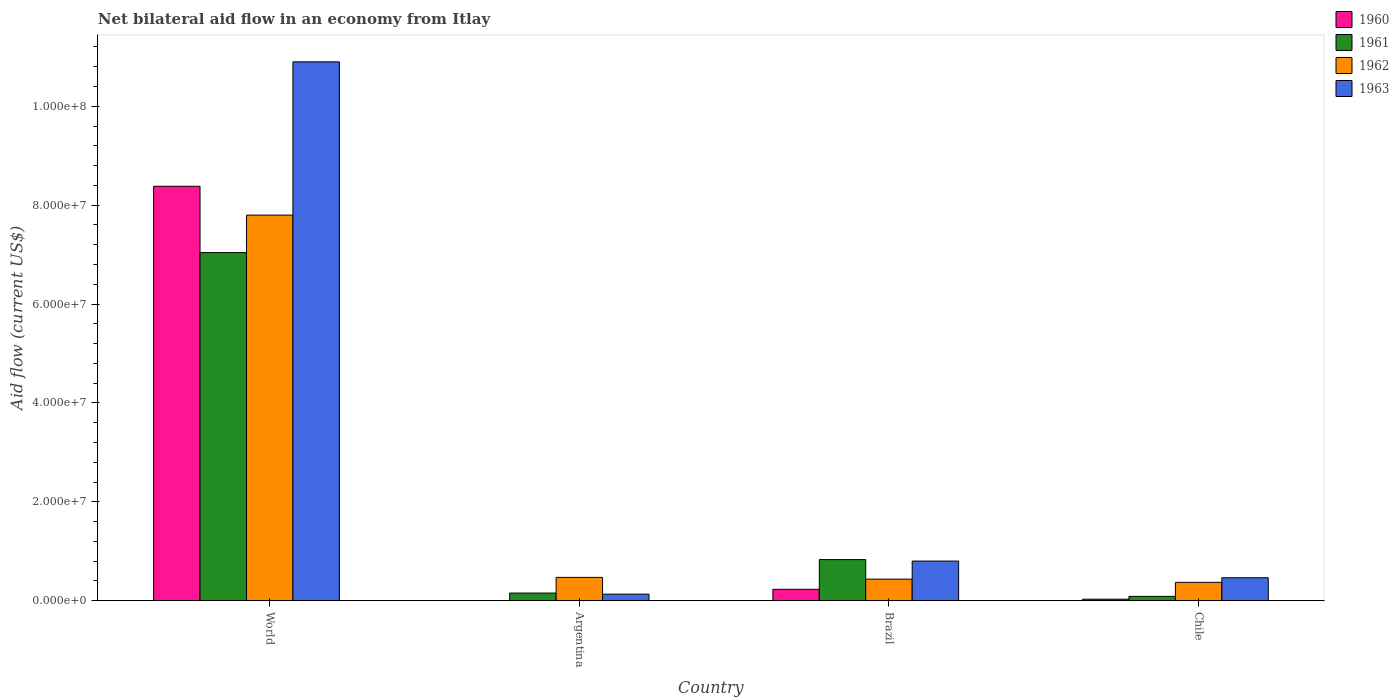How many different coloured bars are there?
Offer a terse response. 4. How many groups of bars are there?
Your answer should be very brief. 4. Are the number of bars per tick equal to the number of legend labels?
Your answer should be compact. No. How many bars are there on the 4th tick from the left?
Provide a short and direct response. 4. How many bars are there on the 4th tick from the right?
Offer a terse response. 4. In how many cases, is the number of bars for a given country not equal to the number of legend labels?
Make the answer very short. 1. What is the net bilateral aid flow in 1961 in Chile?
Your answer should be very brief. 8.90e+05. Across all countries, what is the maximum net bilateral aid flow in 1961?
Offer a terse response. 7.04e+07. In which country was the net bilateral aid flow in 1963 maximum?
Offer a very short reply. World. What is the total net bilateral aid flow in 1963 in the graph?
Make the answer very short. 1.23e+08. What is the difference between the net bilateral aid flow in 1960 in Brazil and that in World?
Your answer should be very brief. -8.15e+07. What is the difference between the net bilateral aid flow in 1961 in Brazil and the net bilateral aid flow in 1962 in Chile?
Provide a succinct answer. 4.60e+06. What is the average net bilateral aid flow in 1961 per country?
Ensure brevity in your answer.  2.03e+07. What is the difference between the net bilateral aid flow of/in 1963 and net bilateral aid flow of/in 1961 in Chile?
Your response must be concise. 3.77e+06. What is the ratio of the net bilateral aid flow in 1961 in Argentina to that in World?
Your response must be concise. 0.02. What is the difference between the highest and the second highest net bilateral aid flow in 1963?
Your response must be concise. 1.04e+08. What is the difference between the highest and the lowest net bilateral aid flow in 1962?
Make the answer very short. 7.43e+07. In how many countries, is the net bilateral aid flow in 1961 greater than the average net bilateral aid flow in 1961 taken over all countries?
Keep it short and to the point. 1. Is the sum of the net bilateral aid flow in 1962 in Argentina and Chile greater than the maximum net bilateral aid flow in 1961 across all countries?
Offer a very short reply. No. Is it the case that in every country, the sum of the net bilateral aid flow in 1963 and net bilateral aid flow in 1960 is greater than the sum of net bilateral aid flow in 1961 and net bilateral aid flow in 1962?
Make the answer very short. No. Are all the bars in the graph horizontal?
Make the answer very short. No. How many countries are there in the graph?
Give a very brief answer. 4. What is the difference between two consecutive major ticks on the Y-axis?
Offer a very short reply. 2.00e+07. Are the values on the major ticks of Y-axis written in scientific E-notation?
Your response must be concise. Yes. Does the graph contain any zero values?
Offer a terse response. Yes. Does the graph contain grids?
Offer a very short reply. No. Where does the legend appear in the graph?
Give a very brief answer. Top right. How many legend labels are there?
Your answer should be very brief. 4. What is the title of the graph?
Offer a terse response. Net bilateral aid flow in an economy from Itlay. Does "1987" appear as one of the legend labels in the graph?
Your answer should be compact. No. What is the label or title of the X-axis?
Provide a short and direct response. Country. What is the Aid flow (current US$) in 1960 in World?
Provide a succinct answer. 8.38e+07. What is the Aid flow (current US$) of 1961 in World?
Your answer should be very brief. 7.04e+07. What is the Aid flow (current US$) in 1962 in World?
Offer a terse response. 7.80e+07. What is the Aid flow (current US$) in 1963 in World?
Your answer should be very brief. 1.09e+08. What is the Aid flow (current US$) of 1960 in Argentina?
Offer a terse response. 0. What is the Aid flow (current US$) of 1961 in Argentina?
Your answer should be very brief. 1.56e+06. What is the Aid flow (current US$) of 1962 in Argentina?
Provide a succinct answer. 4.73e+06. What is the Aid flow (current US$) of 1963 in Argentina?
Your answer should be very brief. 1.34e+06. What is the Aid flow (current US$) in 1960 in Brazil?
Your answer should be very brief. 2.32e+06. What is the Aid flow (current US$) of 1961 in Brazil?
Offer a terse response. 8.33e+06. What is the Aid flow (current US$) of 1962 in Brazil?
Offer a terse response. 4.38e+06. What is the Aid flow (current US$) of 1963 in Brazil?
Provide a succinct answer. 8.03e+06. What is the Aid flow (current US$) in 1961 in Chile?
Offer a very short reply. 8.90e+05. What is the Aid flow (current US$) in 1962 in Chile?
Provide a succinct answer. 3.73e+06. What is the Aid flow (current US$) in 1963 in Chile?
Your answer should be very brief. 4.66e+06. Across all countries, what is the maximum Aid flow (current US$) in 1960?
Provide a succinct answer. 8.38e+07. Across all countries, what is the maximum Aid flow (current US$) in 1961?
Your answer should be very brief. 7.04e+07. Across all countries, what is the maximum Aid flow (current US$) in 1962?
Ensure brevity in your answer.  7.80e+07. Across all countries, what is the maximum Aid flow (current US$) of 1963?
Provide a short and direct response. 1.09e+08. Across all countries, what is the minimum Aid flow (current US$) in 1960?
Your response must be concise. 0. Across all countries, what is the minimum Aid flow (current US$) in 1961?
Offer a terse response. 8.90e+05. Across all countries, what is the minimum Aid flow (current US$) of 1962?
Make the answer very short. 3.73e+06. Across all countries, what is the minimum Aid flow (current US$) in 1963?
Your answer should be very brief. 1.34e+06. What is the total Aid flow (current US$) of 1960 in the graph?
Offer a very short reply. 8.65e+07. What is the total Aid flow (current US$) in 1961 in the graph?
Provide a succinct answer. 8.12e+07. What is the total Aid flow (current US$) in 1962 in the graph?
Keep it short and to the point. 9.08e+07. What is the total Aid flow (current US$) in 1963 in the graph?
Provide a succinct answer. 1.23e+08. What is the difference between the Aid flow (current US$) in 1961 in World and that in Argentina?
Provide a short and direct response. 6.89e+07. What is the difference between the Aid flow (current US$) in 1962 in World and that in Argentina?
Your answer should be compact. 7.33e+07. What is the difference between the Aid flow (current US$) in 1963 in World and that in Argentina?
Give a very brief answer. 1.08e+08. What is the difference between the Aid flow (current US$) in 1960 in World and that in Brazil?
Your response must be concise. 8.15e+07. What is the difference between the Aid flow (current US$) in 1961 in World and that in Brazil?
Make the answer very short. 6.21e+07. What is the difference between the Aid flow (current US$) of 1962 in World and that in Brazil?
Your answer should be very brief. 7.36e+07. What is the difference between the Aid flow (current US$) of 1963 in World and that in Brazil?
Give a very brief answer. 1.01e+08. What is the difference between the Aid flow (current US$) of 1960 in World and that in Chile?
Make the answer very short. 8.35e+07. What is the difference between the Aid flow (current US$) of 1961 in World and that in Chile?
Keep it short and to the point. 6.95e+07. What is the difference between the Aid flow (current US$) of 1962 in World and that in Chile?
Ensure brevity in your answer.  7.43e+07. What is the difference between the Aid flow (current US$) in 1963 in World and that in Chile?
Your answer should be very brief. 1.04e+08. What is the difference between the Aid flow (current US$) of 1961 in Argentina and that in Brazil?
Make the answer very short. -6.77e+06. What is the difference between the Aid flow (current US$) in 1962 in Argentina and that in Brazil?
Keep it short and to the point. 3.50e+05. What is the difference between the Aid flow (current US$) of 1963 in Argentina and that in Brazil?
Offer a terse response. -6.69e+06. What is the difference between the Aid flow (current US$) in 1961 in Argentina and that in Chile?
Give a very brief answer. 6.70e+05. What is the difference between the Aid flow (current US$) of 1962 in Argentina and that in Chile?
Keep it short and to the point. 1.00e+06. What is the difference between the Aid flow (current US$) in 1963 in Argentina and that in Chile?
Ensure brevity in your answer.  -3.32e+06. What is the difference between the Aid flow (current US$) in 1961 in Brazil and that in Chile?
Your response must be concise. 7.44e+06. What is the difference between the Aid flow (current US$) in 1962 in Brazil and that in Chile?
Give a very brief answer. 6.50e+05. What is the difference between the Aid flow (current US$) of 1963 in Brazil and that in Chile?
Ensure brevity in your answer.  3.37e+06. What is the difference between the Aid flow (current US$) in 1960 in World and the Aid flow (current US$) in 1961 in Argentina?
Give a very brief answer. 8.23e+07. What is the difference between the Aid flow (current US$) in 1960 in World and the Aid flow (current US$) in 1962 in Argentina?
Offer a very short reply. 7.91e+07. What is the difference between the Aid flow (current US$) of 1960 in World and the Aid flow (current US$) of 1963 in Argentina?
Your answer should be very brief. 8.25e+07. What is the difference between the Aid flow (current US$) of 1961 in World and the Aid flow (current US$) of 1962 in Argentina?
Offer a very short reply. 6.57e+07. What is the difference between the Aid flow (current US$) of 1961 in World and the Aid flow (current US$) of 1963 in Argentina?
Ensure brevity in your answer.  6.91e+07. What is the difference between the Aid flow (current US$) in 1962 in World and the Aid flow (current US$) in 1963 in Argentina?
Offer a very short reply. 7.67e+07. What is the difference between the Aid flow (current US$) in 1960 in World and the Aid flow (current US$) in 1961 in Brazil?
Your response must be concise. 7.55e+07. What is the difference between the Aid flow (current US$) in 1960 in World and the Aid flow (current US$) in 1962 in Brazil?
Offer a terse response. 7.94e+07. What is the difference between the Aid flow (current US$) of 1960 in World and the Aid flow (current US$) of 1963 in Brazil?
Provide a succinct answer. 7.58e+07. What is the difference between the Aid flow (current US$) of 1961 in World and the Aid flow (current US$) of 1962 in Brazil?
Keep it short and to the point. 6.60e+07. What is the difference between the Aid flow (current US$) of 1961 in World and the Aid flow (current US$) of 1963 in Brazil?
Give a very brief answer. 6.24e+07. What is the difference between the Aid flow (current US$) of 1962 in World and the Aid flow (current US$) of 1963 in Brazil?
Give a very brief answer. 7.00e+07. What is the difference between the Aid flow (current US$) in 1960 in World and the Aid flow (current US$) in 1961 in Chile?
Offer a terse response. 8.29e+07. What is the difference between the Aid flow (current US$) in 1960 in World and the Aid flow (current US$) in 1962 in Chile?
Make the answer very short. 8.01e+07. What is the difference between the Aid flow (current US$) in 1960 in World and the Aid flow (current US$) in 1963 in Chile?
Provide a succinct answer. 7.92e+07. What is the difference between the Aid flow (current US$) of 1961 in World and the Aid flow (current US$) of 1962 in Chile?
Ensure brevity in your answer.  6.67e+07. What is the difference between the Aid flow (current US$) of 1961 in World and the Aid flow (current US$) of 1963 in Chile?
Your answer should be very brief. 6.58e+07. What is the difference between the Aid flow (current US$) in 1962 in World and the Aid flow (current US$) in 1963 in Chile?
Offer a terse response. 7.33e+07. What is the difference between the Aid flow (current US$) of 1961 in Argentina and the Aid flow (current US$) of 1962 in Brazil?
Provide a short and direct response. -2.82e+06. What is the difference between the Aid flow (current US$) in 1961 in Argentina and the Aid flow (current US$) in 1963 in Brazil?
Keep it short and to the point. -6.47e+06. What is the difference between the Aid flow (current US$) of 1962 in Argentina and the Aid flow (current US$) of 1963 in Brazil?
Your response must be concise. -3.30e+06. What is the difference between the Aid flow (current US$) in 1961 in Argentina and the Aid flow (current US$) in 1962 in Chile?
Your response must be concise. -2.17e+06. What is the difference between the Aid flow (current US$) in 1961 in Argentina and the Aid flow (current US$) in 1963 in Chile?
Give a very brief answer. -3.10e+06. What is the difference between the Aid flow (current US$) in 1962 in Argentina and the Aid flow (current US$) in 1963 in Chile?
Give a very brief answer. 7.00e+04. What is the difference between the Aid flow (current US$) in 1960 in Brazil and the Aid flow (current US$) in 1961 in Chile?
Your answer should be very brief. 1.43e+06. What is the difference between the Aid flow (current US$) in 1960 in Brazil and the Aid flow (current US$) in 1962 in Chile?
Make the answer very short. -1.41e+06. What is the difference between the Aid flow (current US$) in 1960 in Brazil and the Aid flow (current US$) in 1963 in Chile?
Offer a terse response. -2.34e+06. What is the difference between the Aid flow (current US$) of 1961 in Brazil and the Aid flow (current US$) of 1962 in Chile?
Offer a very short reply. 4.60e+06. What is the difference between the Aid flow (current US$) in 1961 in Brazil and the Aid flow (current US$) in 1963 in Chile?
Ensure brevity in your answer.  3.67e+06. What is the difference between the Aid flow (current US$) in 1962 in Brazil and the Aid flow (current US$) in 1963 in Chile?
Offer a very short reply. -2.80e+05. What is the average Aid flow (current US$) of 1960 per country?
Give a very brief answer. 2.16e+07. What is the average Aid flow (current US$) in 1961 per country?
Give a very brief answer. 2.03e+07. What is the average Aid flow (current US$) in 1962 per country?
Your answer should be compact. 2.27e+07. What is the average Aid flow (current US$) of 1963 per country?
Your answer should be very brief. 3.08e+07. What is the difference between the Aid flow (current US$) in 1960 and Aid flow (current US$) in 1961 in World?
Provide a short and direct response. 1.34e+07. What is the difference between the Aid flow (current US$) in 1960 and Aid flow (current US$) in 1962 in World?
Offer a terse response. 5.83e+06. What is the difference between the Aid flow (current US$) in 1960 and Aid flow (current US$) in 1963 in World?
Offer a terse response. -2.52e+07. What is the difference between the Aid flow (current US$) in 1961 and Aid flow (current US$) in 1962 in World?
Provide a succinct answer. -7.58e+06. What is the difference between the Aid flow (current US$) in 1961 and Aid flow (current US$) in 1963 in World?
Provide a succinct answer. -3.86e+07. What is the difference between the Aid flow (current US$) in 1962 and Aid flow (current US$) in 1963 in World?
Your response must be concise. -3.10e+07. What is the difference between the Aid flow (current US$) in 1961 and Aid flow (current US$) in 1962 in Argentina?
Your response must be concise. -3.17e+06. What is the difference between the Aid flow (current US$) of 1961 and Aid flow (current US$) of 1963 in Argentina?
Offer a very short reply. 2.20e+05. What is the difference between the Aid flow (current US$) of 1962 and Aid flow (current US$) of 1963 in Argentina?
Offer a very short reply. 3.39e+06. What is the difference between the Aid flow (current US$) in 1960 and Aid flow (current US$) in 1961 in Brazil?
Make the answer very short. -6.01e+06. What is the difference between the Aid flow (current US$) of 1960 and Aid flow (current US$) of 1962 in Brazil?
Your answer should be very brief. -2.06e+06. What is the difference between the Aid flow (current US$) of 1960 and Aid flow (current US$) of 1963 in Brazil?
Provide a short and direct response. -5.71e+06. What is the difference between the Aid flow (current US$) of 1961 and Aid flow (current US$) of 1962 in Brazil?
Provide a short and direct response. 3.95e+06. What is the difference between the Aid flow (current US$) in 1962 and Aid flow (current US$) in 1963 in Brazil?
Provide a short and direct response. -3.65e+06. What is the difference between the Aid flow (current US$) in 1960 and Aid flow (current US$) in 1961 in Chile?
Your response must be concise. -5.70e+05. What is the difference between the Aid flow (current US$) of 1960 and Aid flow (current US$) of 1962 in Chile?
Your answer should be compact. -3.41e+06. What is the difference between the Aid flow (current US$) in 1960 and Aid flow (current US$) in 1963 in Chile?
Your answer should be very brief. -4.34e+06. What is the difference between the Aid flow (current US$) in 1961 and Aid flow (current US$) in 1962 in Chile?
Provide a succinct answer. -2.84e+06. What is the difference between the Aid flow (current US$) of 1961 and Aid flow (current US$) of 1963 in Chile?
Give a very brief answer. -3.77e+06. What is the difference between the Aid flow (current US$) of 1962 and Aid flow (current US$) of 1963 in Chile?
Give a very brief answer. -9.30e+05. What is the ratio of the Aid flow (current US$) of 1961 in World to that in Argentina?
Provide a short and direct response. 45.14. What is the ratio of the Aid flow (current US$) in 1962 in World to that in Argentina?
Keep it short and to the point. 16.49. What is the ratio of the Aid flow (current US$) of 1963 in World to that in Argentina?
Offer a terse response. 81.34. What is the ratio of the Aid flow (current US$) in 1960 in World to that in Brazil?
Your answer should be compact. 36.13. What is the ratio of the Aid flow (current US$) in 1961 in World to that in Brazil?
Offer a terse response. 8.45. What is the ratio of the Aid flow (current US$) in 1962 in World to that in Brazil?
Keep it short and to the point. 17.81. What is the ratio of the Aid flow (current US$) of 1963 in World to that in Brazil?
Ensure brevity in your answer.  13.57. What is the ratio of the Aid flow (current US$) in 1960 in World to that in Chile?
Your answer should be compact. 261.97. What is the ratio of the Aid flow (current US$) in 1961 in World to that in Chile?
Your response must be concise. 79.12. What is the ratio of the Aid flow (current US$) of 1962 in World to that in Chile?
Offer a terse response. 20.91. What is the ratio of the Aid flow (current US$) of 1963 in World to that in Chile?
Your answer should be compact. 23.39. What is the ratio of the Aid flow (current US$) of 1961 in Argentina to that in Brazil?
Your answer should be very brief. 0.19. What is the ratio of the Aid flow (current US$) of 1962 in Argentina to that in Brazil?
Offer a terse response. 1.08. What is the ratio of the Aid flow (current US$) in 1963 in Argentina to that in Brazil?
Make the answer very short. 0.17. What is the ratio of the Aid flow (current US$) in 1961 in Argentina to that in Chile?
Provide a short and direct response. 1.75. What is the ratio of the Aid flow (current US$) in 1962 in Argentina to that in Chile?
Your answer should be compact. 1.27. What is the ratio of the Aid flow (current US$) of 1963 in Argentina to that in Chile?
Your answer should be compact. 0.29. What is the ratio of the Aid flow (current US$) in 1960 in Brazil to that in Chile?
Ensure brevity in your answer.  7.25. What is the ratio of the Aid flow (current US$) of 1961 in Brazil to that in Chile?
Make the answer very short. 9.36. What is the ratio of the Aid flow (current US$) of 1962 in Brazil to that in Chile?
Offer a very short reply. 1.17. What is the ratio of the Aid flow (current US$) of 1963 in Brazil to that in Chile?
Your response must be concise. 1.72. What is the difference between the highest and the second highest Aid flow (current US$) of 1960?
Give a very brief answer. 8.15e+07. What is the difference between the highest and the second highest Aid flow (current US$) of 1961?
Your answer should be compact. 6.21e+07. What is the difference between the highest and the second highest Aid flow (current US$) in 1962?
Your response must be concise. 7.33e+07. What is the difference between the highest and the second highest Aid flow (current US$) of 1963?
Your answer should be very brief. 1.01e+08. What is the difference between the highest and the lowest Aid flow (current US$) in 1960?
Your answer should be compact. 8.38e+07. What is the difference between the highest and the lowest Aid flow (current US$) in 1961?
Keep it short and to the point. 6.95e+07. What is the difference between the highest and the lowest Aid flow (current US$) of 1962?
Your response must be concise. 7.43e+07. What is the difference between the highest and the lowest Aid flow (current US$) of 1963?
Offer a very short reply. 1.08e+08. 